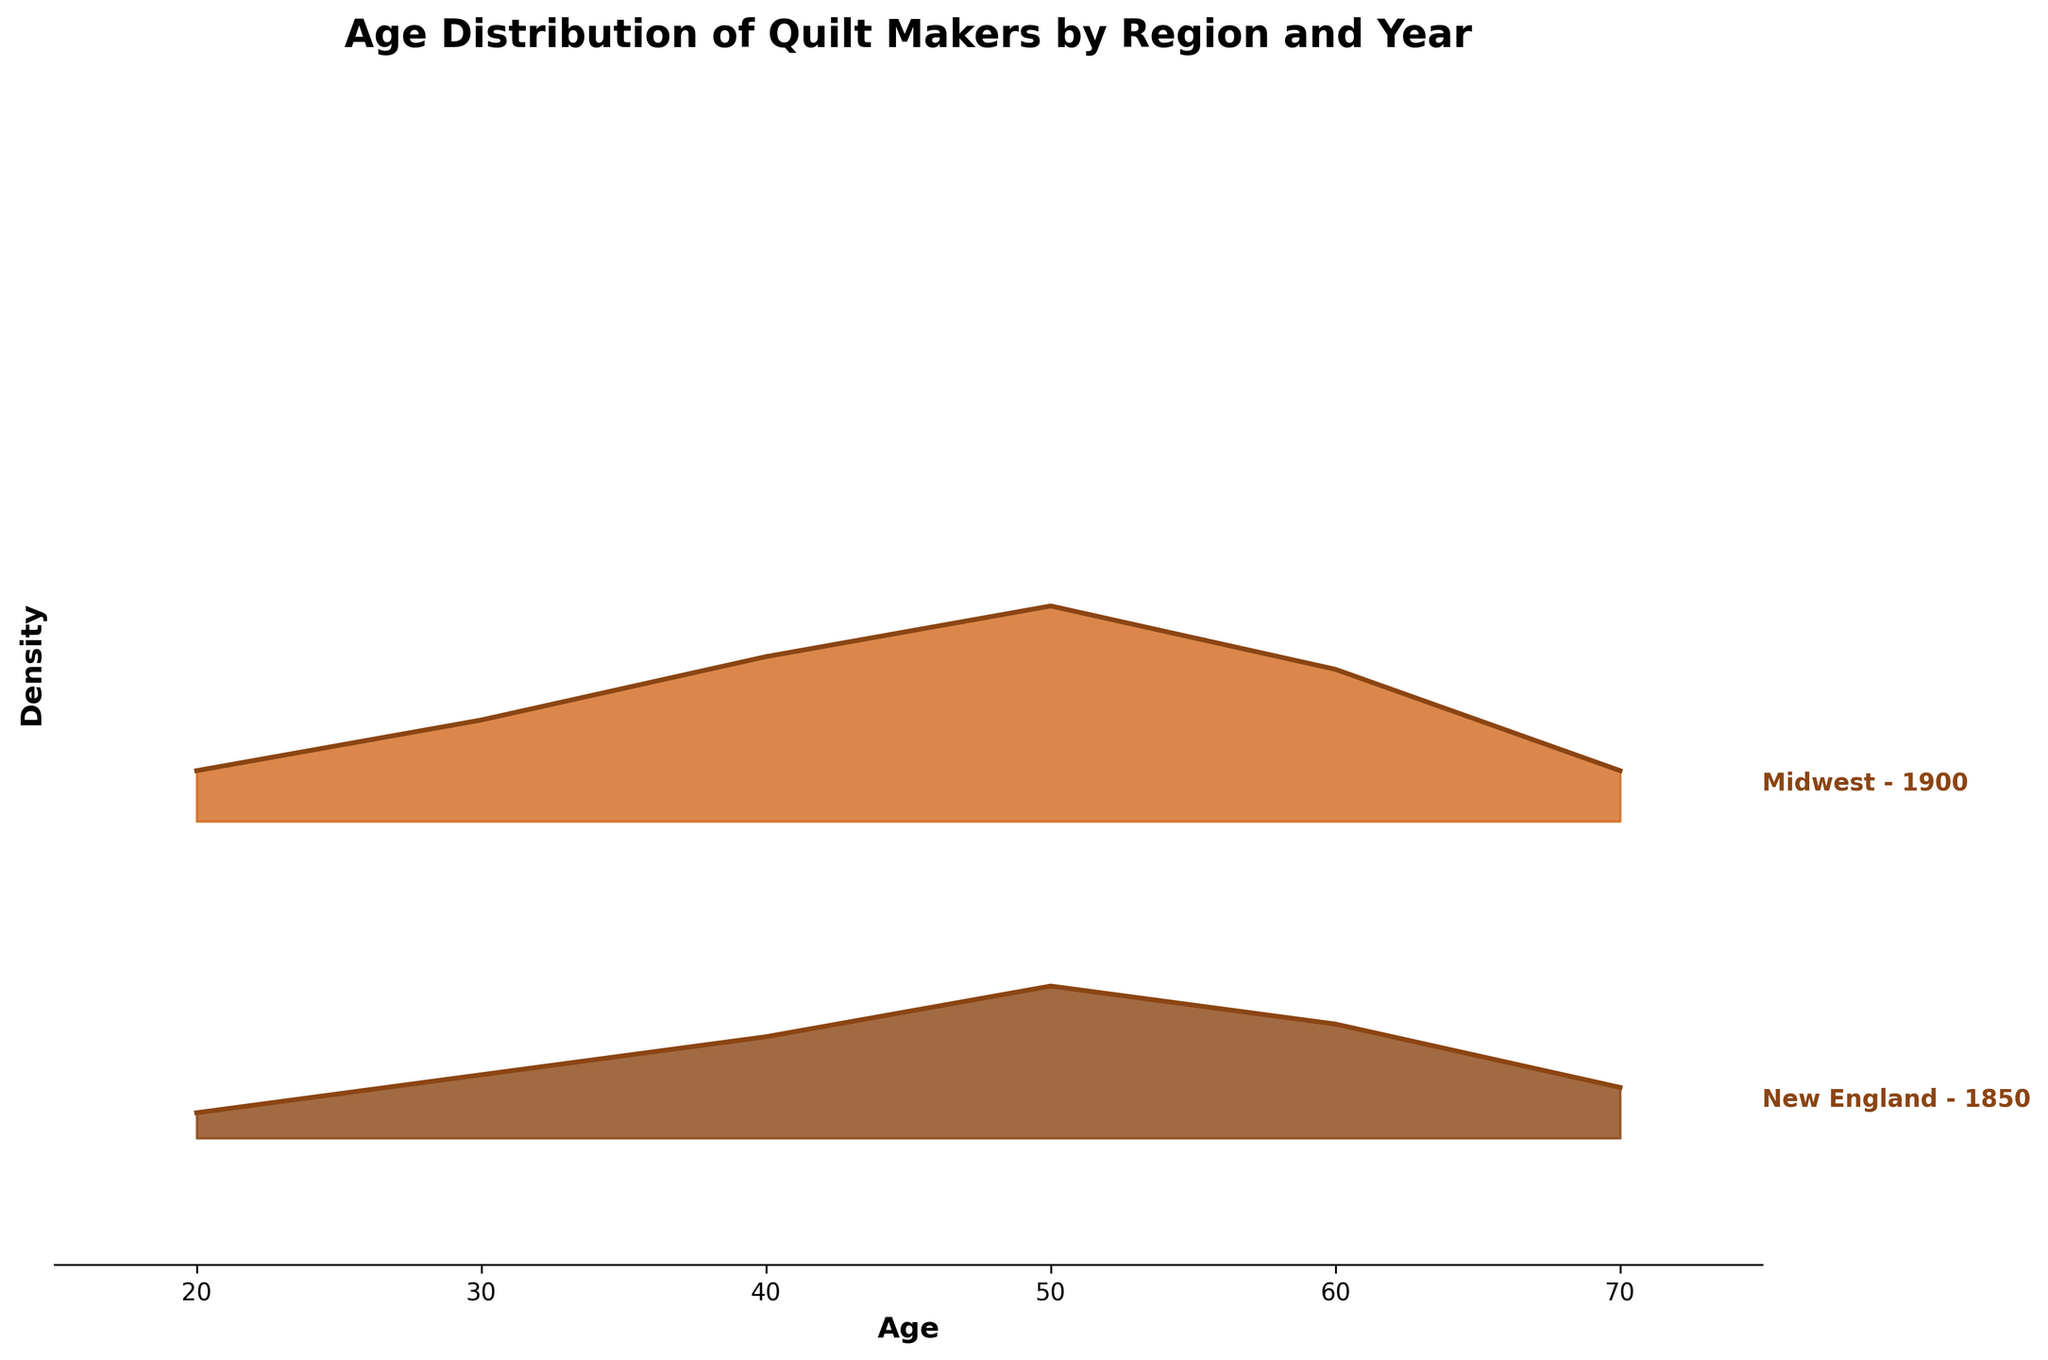What is the title of the figure? The title is typically located at the top of the figure and provides a summary of what the plot is about. The title here is "Age Distribution of Quilt Makers by Region and Year."
Answer: Age Distribution of Quilt Makers by Region and Year Which region has the highest density of quilt makers aged 50 in the year 1850? From the plot, we look at the density peaks at age 50 for each region in the year 1850. The region must be identified by its higher peak at age 50. The South shows the highest density at age 50.
Answer: South How does the density of quilt makers aged 30 in the year 1900 compare between New England and the Midwest? To compare densities, locate the age of 30 for both New England and Midwest in 1900. New England has a density of 0.06, while Midwest has 0.08. The Midwest has a slightly higher density than New England.
Answer: Midwest has a higher density What is the general trend in the peak density of quilt makers aged 60 from 1850 to 1900 across all regions? Look at the changes in peak densities at age 60 from 1850 to 1900 across New England, Midwest, and South. All regions show an increase in peak density at age 60 from 1850 to 1900.
Answer: Increasing trend Which region has the broadest age distribution of quilt makers in 1900, and how can you tell? The broadest age distribution can be identified by looking at the width of the distribution curves. The region with the widest spread is the one with the least steep curves. The South has the broadest distribution with wider curves.
Answer: South Comparing the densities at age 40 in 1850 and 1900 for the Midwest, what trend is visible? Observe the density values for age 40 in the Midwest for both years. In 1850, the density is 0.11; in 1900, it’s 0.13. There is a slight increase in density from 1850 to 1900.
Answer: Increasing trend At what age and year do quilt makers show the lowest density in the South? Identify the minimum density value in the South region across all ages. The lowest density is at age 70 in 1850 with a value of 0.02.
Answer: Age 70 in 1850 What can you infer about the age trend of quilt makers in New England from 1850 to 1900? Analyze the peak densities in New England for both years. The density peaks are slightly higher and the distributions are more spread out in 1900, indicating more quilt makers and a wider age range in 1900.
Answer: More quilt makers and wider age range in 1900 Which age group of quilt makers is the most common across all regions in the year 1900? Compare the peak densities of all age groups across all regions in 1900. The highest peak density appears consistently around age 50 across all regions.
Answer: Age 50 How does the peak density trend for quilt makers aged 70 change from 1850 to 1900 for all regions combined? By comparing the height of density peaks for age 70 in both years for all regions, we see that densities increase slightly from 1850 to 1900, indicating more quilt makers aged 70 in 1900.
Answer: Increasing trend 